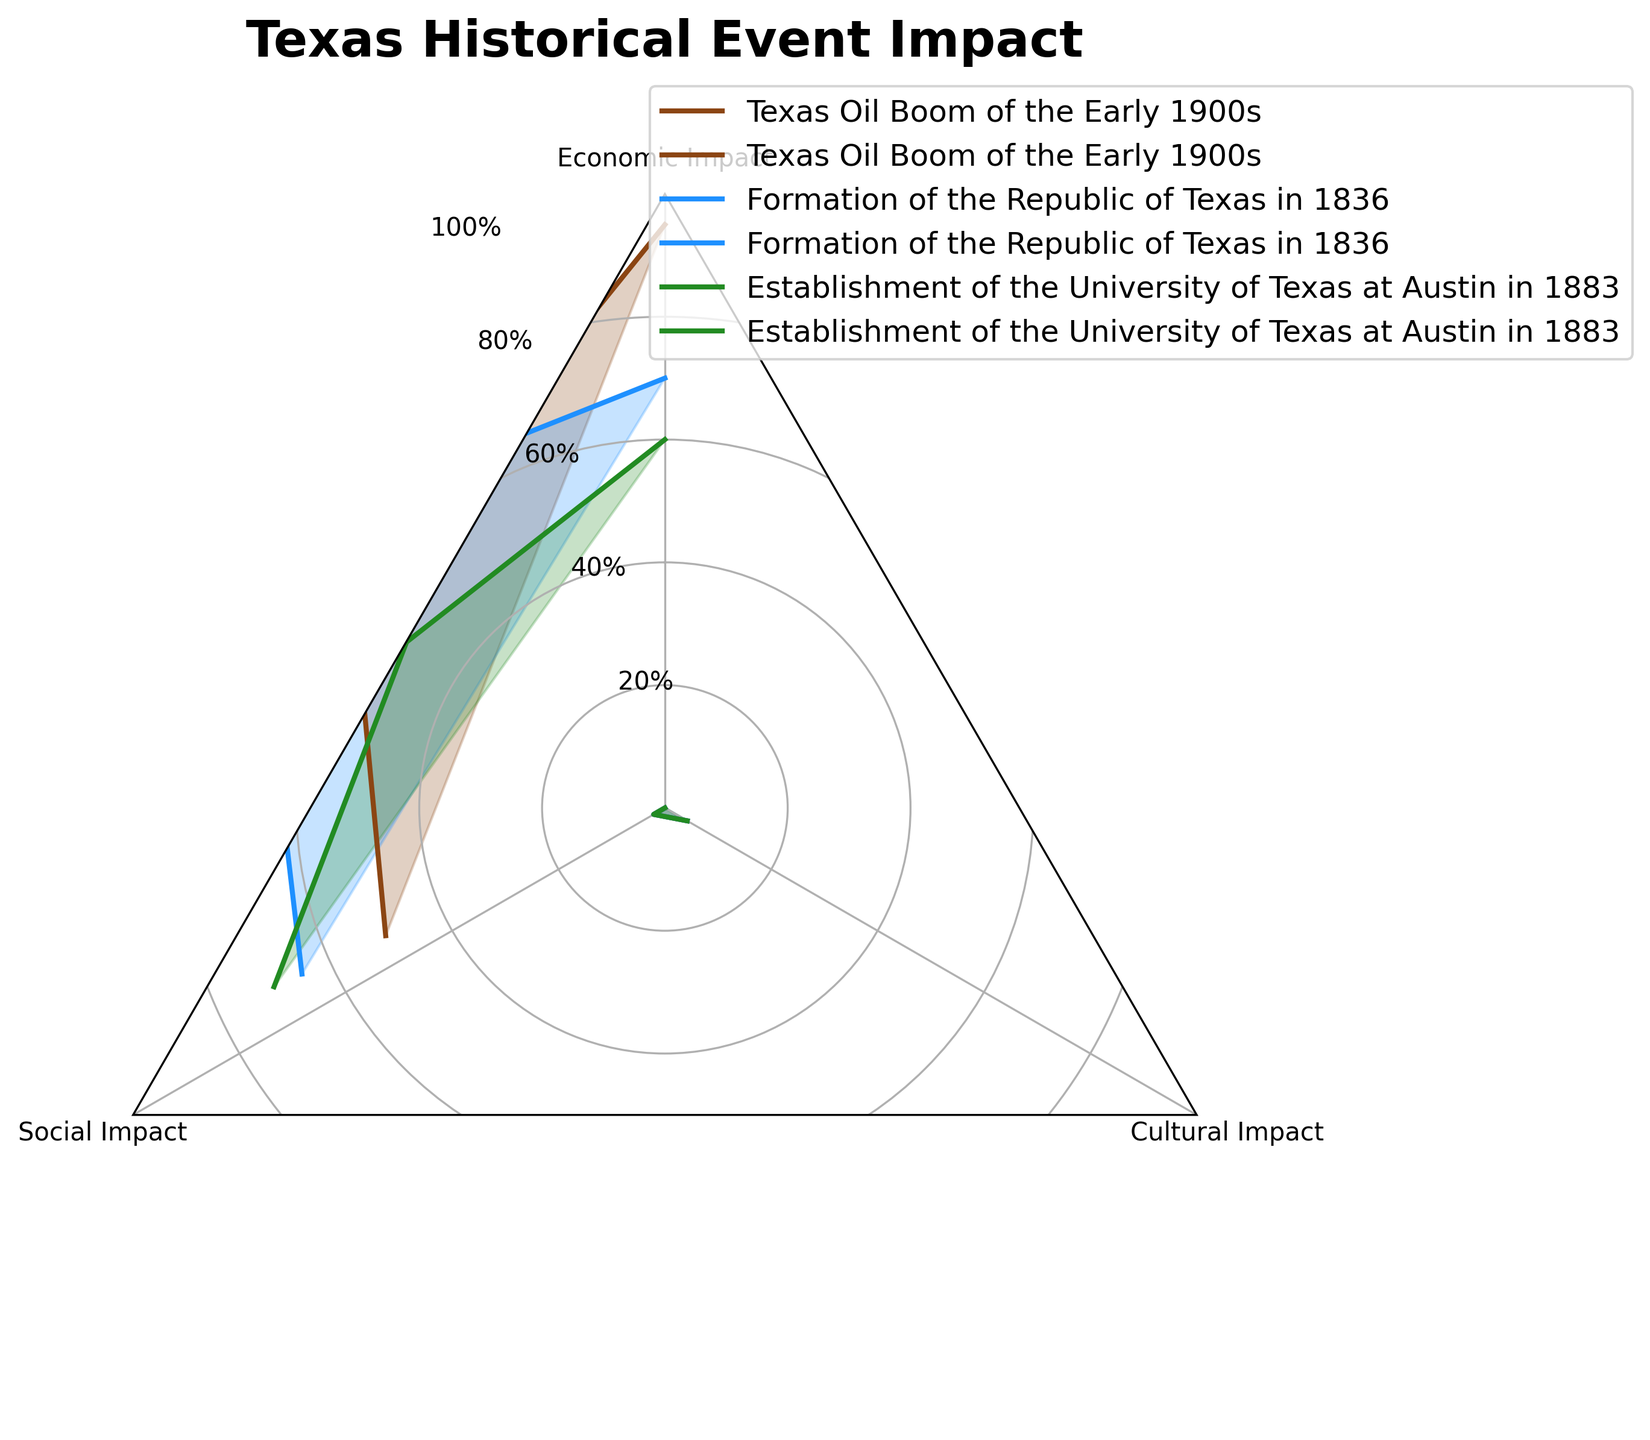What is the title of the radar chart? The title is usually found at the top of the chart. In this case, it reads, "Texas Historical Event Impact".
Answer: Texas Historical Event Impact How many categories are displayed in this radar chart? By looking at the number of axis labels, we see that the chart has three categories: Economic Impact, Social Impact, and Cultural Impact.
Answer: 3 Which event has the highest Social Impact rating? By examining the values on the radar chart, we see three events and their Social Impact ratings. The Formation of the Republic of Texas in 1836 has the highest rating.
Answer: Formation of the Republic of Texas in 1836 In which category does the Formation of the Republic of Texas in 1836 have the lowest impact? For the Formation of the Republic of Texas in 1836, check the values for Economic, Social, and Cultural Impacts. The Economic Impact has the lowest value (70).
Answer: Economic Impact Compare the Cultural Impact of the Texas Oil Boom and the Establishment of the University of Texas at Austin. Which is higher? By comparing the Cultural Impact values on the radar chart for both events, it is clear that the Establishment of the University of Texas at Austin has the higher value (90 vs. 85).
Answer: Establishment of the University of Texas at Austin What is the average Economic Impact across all events? Summing the Economic Impact values of all events (95 + 70 + 60) and then dividing by the number of events (3), we get an average of (225 / 3) = 75.
Answer: 75 For the Texas Oil Boom, how does the Social Impact compare to the Cultural Impact? By checking the radar chart, the Social Impact for the Texas Oil Boom (75) is higher than the Cultural Impact (70).
Answer: Social Impact is higher Which event shows the most balanced impact across all three categories? The most balanced impact can be determined by checking how close the values are in each category for each event. The Establishment of the University of Texas at Austin has relatively close values in all three categories (60, 85, 90).
Answer: Establishment of the University of Texas at Austin What is the combined impact score (sum of Economic, Social, and Cultural impacts) of the Texas Oil Boom? Adding the three impacts for the Texas Oil Boom of the Early 1900s: 95 (Economic) + 75 (Social) + 85 (Cultural) = 255.
Answer: 255 